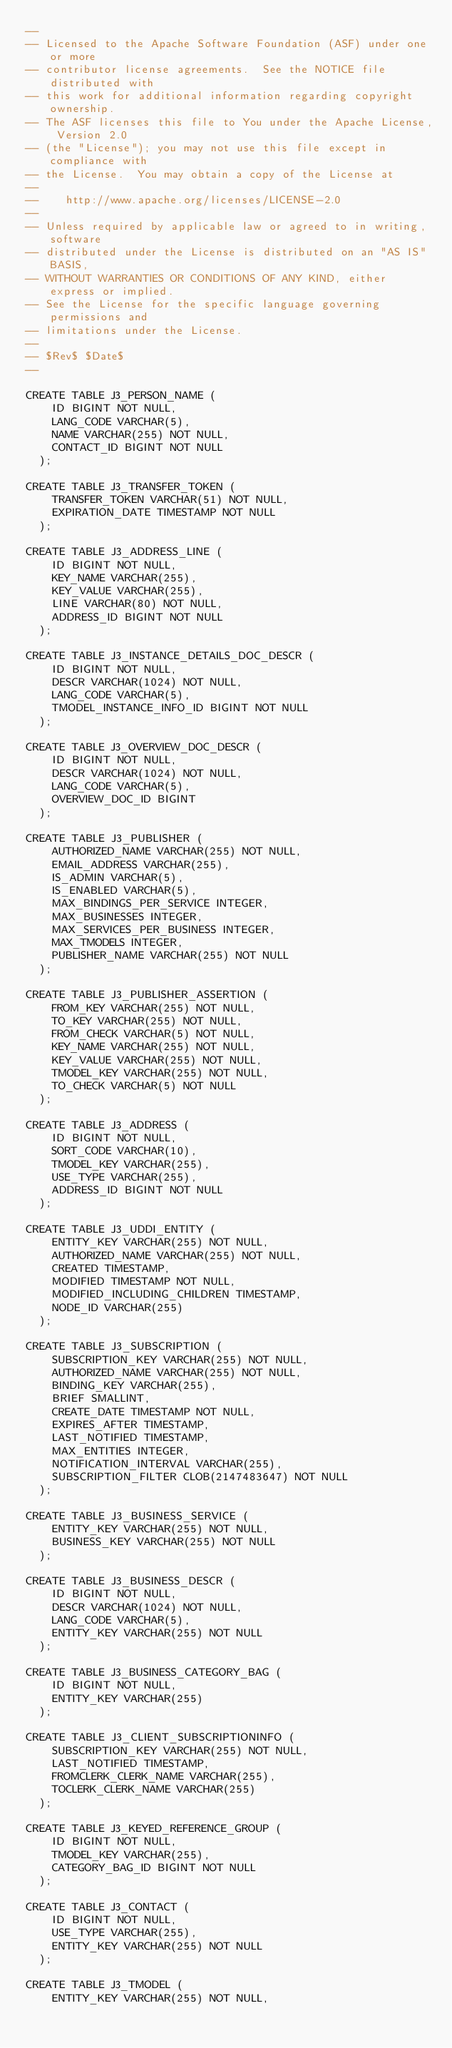Convert code to text. <code><loc_0><loc_0><loc_500><loc_500><_SQL_>--
-- Licensed to the Apache Software Foundation (ASF) under one or more
-- contributor license agreements.  See the NOTICE file distributed with
-- this work for additional information regarding copyright ownership.
-- The ASF licenses this file to You under the Apache License, Version 2.0
-- (the "License"); you may not use this file except in compliance with
-- the License.  You may obtain a copy of the License at
--
--    http://www.apache.org/licenses/LICENSE-2.0
--
-- Unless required by applicable law or agreed to in writing, software
-- distributed under the License is distributed on an "AS IS" BASIS,
-- WITHOUT WARRANTIES OR CONDITIONS OF ANY KIND, either express or implied.
-- See the License for the specific language governing permissions and
-- limitations under the License.
--
-- $Rev$ $Date$
--

CREATE TABLE J3_PERSON_NAME (
    ID BIGINT NOT NULL,
    LANG_CODE VARCHAR(5),
    NAME VARCHAR(255) NOT NULL,
    CONTACT_ID BIGINT NOT NULL
  );

CREATE TABLE J3_TRANSFER_TOKEN (
    TRANSFER_TOKEN VARCHAR(51) NOT NULL,
    EXPIRATION_DATE TIMESTAMP NOT NULL
  );

CREATE TABLE J3_ADDRESS_LINE (
    ID BIGINT NOT NULL,
    KEY_NAME VARCHAR(255),
    KEY_VALUE VARCHAR(255),
    LINE VARCHAR(80) NOT NULL,
    ADDRESS_ID BIGINT NOT NULL
  );

CREATE TABLE J3_INSTANCE_DETAILS_DOC_DESCR (
    ID BIGINT NOT NULL,
    DESCR VARCHAR(1024) NOT NULL,
    LANG_CODE VARCHAR(5),
    TMODEL_INSTANCE_INFO_ID BIGINT NOT NULL
  );

CREATE TABLE J3_OVERVIEW_DOC_DESCR (
    ID BIGINT NOT NULL,
    DESCR VARCHAR(1024) NOT NULL,
    LANG_CODE VARCHAR(5),
    OVERVIEW_DOC_ID BIGINT
  );

CREATE TABLE J3_PUBLISHER (
    AUTHORIZED_NAME VARCHAR(255) NOT NULL,
    EMAIL_ADDRESS VARCHAR(255),
    IS_ADMIN VARCHAR(5),
    IS_ENABLED VARCHAR(5),
    MAX_BINDINGS_PER_SERVICE INTEGER,
    MAX_BUSINESSES INTEGER,
    MAX_SERVICES_PER_BUSINESS INTEGER,
    MAX_TMODELS INTEGER,
    PUBLISHER_NAME VARCHAR(255) NOT NULL
  );

CREATE TABLE J3_PUBLISHER_ASSERTION (
    FROM_KEY VARCHAR(255) NOT NULL,
    TO_KEY VARCHAR(255) NOT NULL,
    FROM_CHECK VARCHAR(5) NOT NULL,
    KEY_NAME VARCHAR(255) NOT NULL,
    KEY_VALUE VARCHAR(255) NOT NULL,
    TMODEL_KEY VARCHAR(255) NOT NULL,
    TO_CHECK VARCHAR(5) NOT NULL
  );

CREATE TABLE J3_ADDRESS (
    ID BIGINT NOT NULL,
    SORT_CODE VARCHAR(10),
    TMODEL_KEY VARCHAR(255),
    USE_TYPE VARCHAR(255),
    ADDRESS_ID BIGINT NOT NULL
  );

CREATE TABLE J3_UDDI_ENTITY (
    ENTITY_KEY VARCHAR(255) NOT NULL,
    AUTHORIZED_NAME VARCHAR(255) NOT NULL,
    CREATED TIMESTAMP,
    MODIFIED TIMESTAMP NOT NULL,
    MODIFIED_INCLUDING_CHILDREN TIMESTAMP,
    NODE_ID VARCHAR(255)
  );

CREATE TABLE J3_SUBSCRIPTION (
    SUBSCRIPTION_KEY VARCHAR(255) NOT NULL,
    AUTHORIZED_NAME VARCHAR(255) NOT NULL,
    BINDING_KEY VARCHAR(255),
    BRIEF SMALLINT,
    CREATE_DATE TIMESTAMP NOT NULL,
    EXPIRES_AFTER TIMESTAMP,
    LAST_NOTIFIED TIMESTAMP,
    MAX_ENTITIES INTEGER,
    NOTIFICATION_INTERVAL VARCHAR(255),
    SUBSCRIPTION_FILTER CLOB(2147483647) NOT NULL
  );

CREATE TABLE J3_BUSINESS_SERVICE (
    ENTITY_KEY VARCHAR(255) NOT NULL,
    BUSINESS_KEY VARCHAR(255) NOT NULL
  );

CREATE TABLE J3_BUSINESS_DESCR (
    ID BIGINT NOT NULL,
    DESCR VARCHAR(1024) NOT NULL,
    LANG_CODE VARCHAR(5),
    ENTITY_KEY VARCHAR(255) NOT NULL
  );

CREATE TABLE J3_BUSINESS_CATEGORY_BAG (
    ID BIGINT NOT NULL,
    ENTITY_KEY VARCHAR(255)
  );

CREATE TABLE J3_CLIENT_SUBSCRIPTIONINFO (
    SUBSCRIPTION_KEY VARCHAR(255) NOT NULL,
    LAST_NOTIFIED TIMESTAMP,
    FROMCLERK_CLERK_NAME VARCHAR(255),
    TOCLERK_CLERK_NAME VARCHAR(255)
  );

CREATE TABLE J3_KEYED_REFERENCE_GROUP (
    ID BIGINT NOT NULL,
    TMODEL_KEY VARCHAR(255),
    CATEGORY_BAG_ID BIGINT NOT NULL
  );

CREATE TABLE J3_CONTACT (
    ID BIGINT NOT NULL,
    USE_TYPE VARCHAR(255),
    ENTITY_KEY VARCHAR(255) NOT NULL
  );

CREATE TABLE J3_TMODEL (
    ENTITY_KEY VARCHAR(255) NOT NULL,</code> 